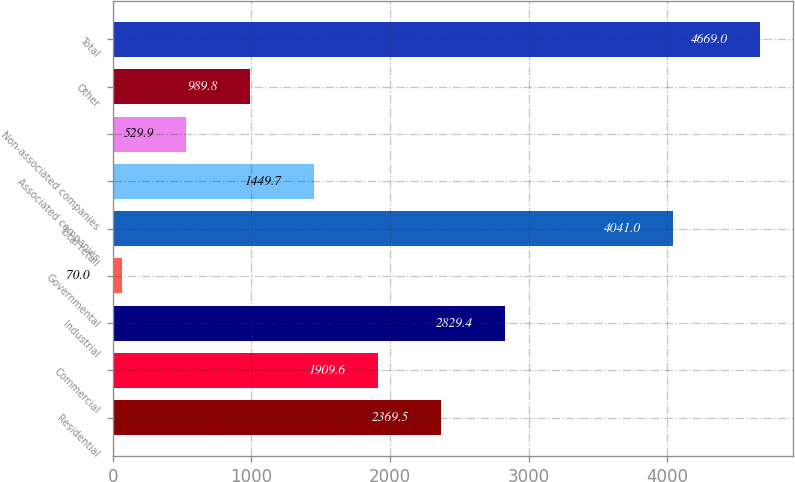<chart> <loc_0><loc_0><loc_500><loc_500><bar_chart><fcel>Residential<fcel>Commercial<fcel>Industrial<fcel>Governmental<fcel>Total retail<fcel>Associated companies<fcel>Non-associated companies<fcel>Other<fcel>Total<nl><fcel>2369.5<fcel>1909.6<fcel>2829.4<fcel>70<fcel>4041<fcel>1449.7<fcel>529.9<fcel>989.8<fcel>4669<nl></chart> 